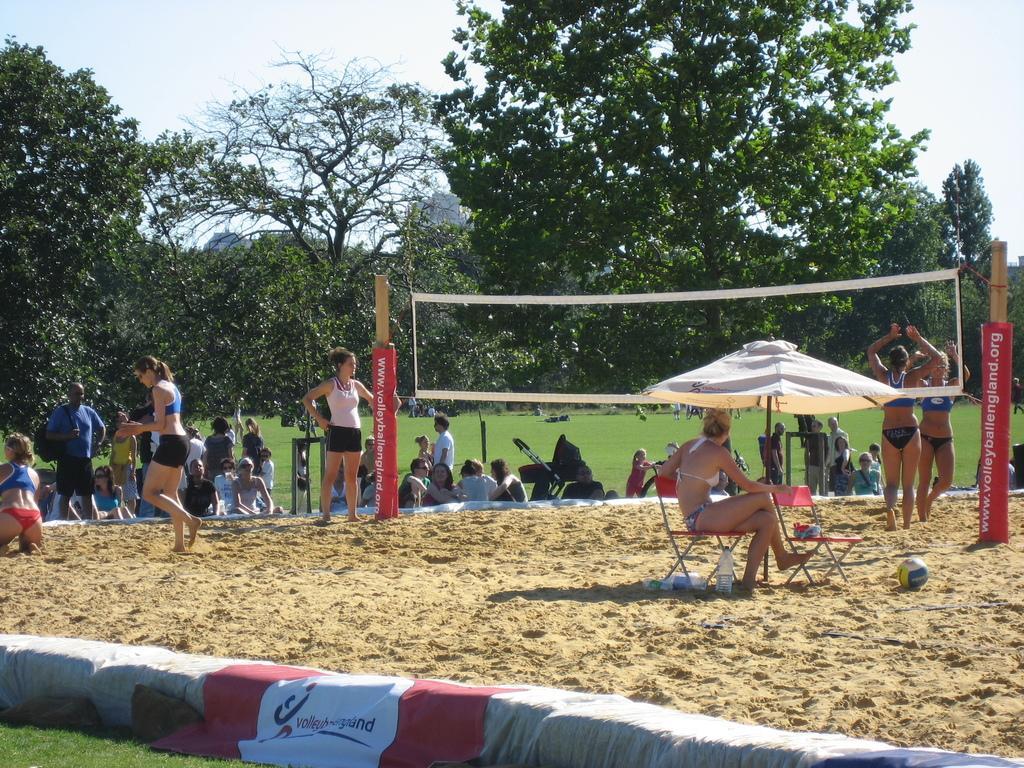Can you describe this image briefly? In this image I can see there are crowd of people and in the middle I can see two poles and tents and I can see a woman siting on chair and beside the woman I can see another chair and ball and bottle ,at the top I can see trees and the sky and at the bottom I can see small fence. 